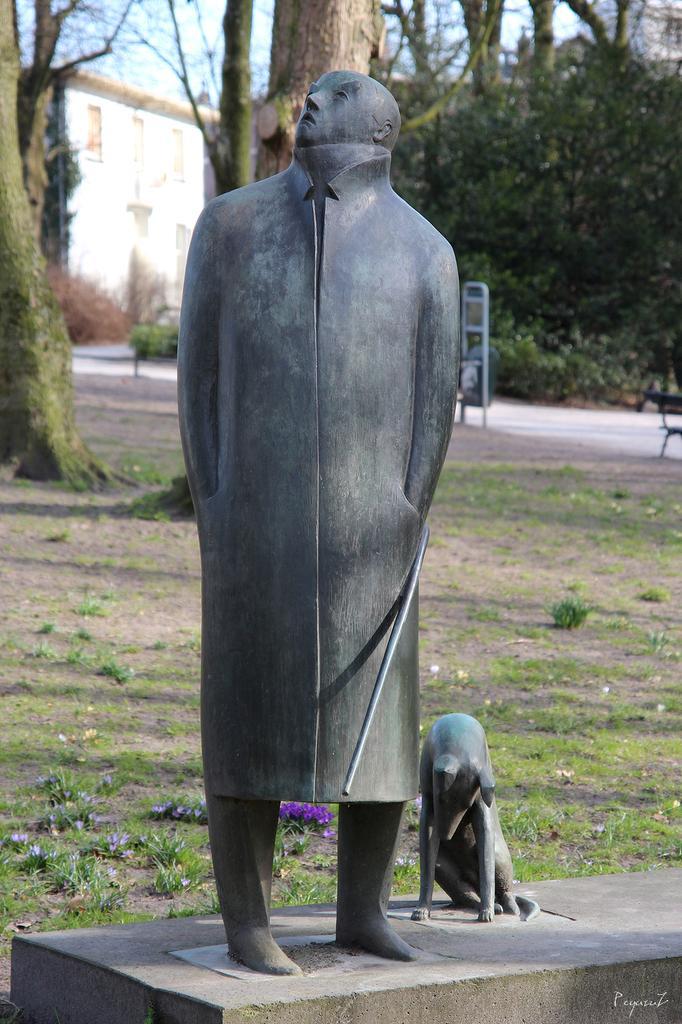Could you give a brief overview of what you see in this image? This image consist of statue which is in the center and in the background there are trees, there is a building, and there is grass on the ground. 